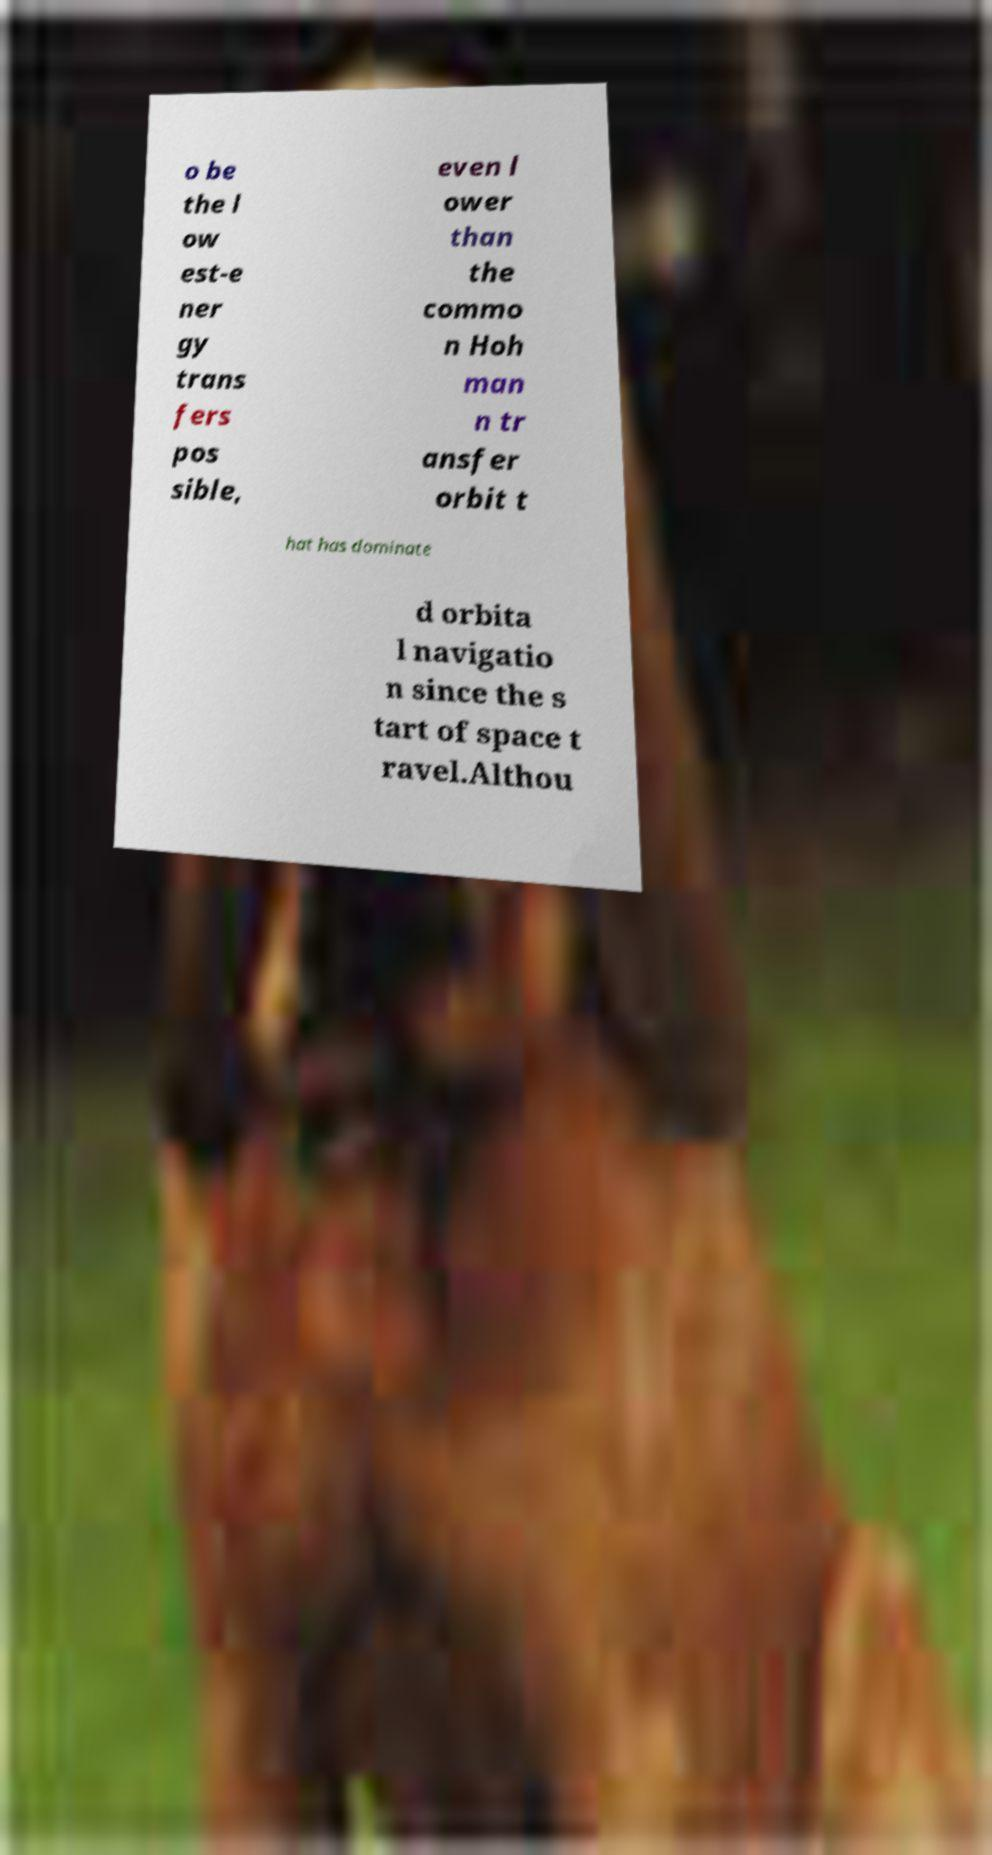Could you assist in decoding the text presented in this image and type it out clearly? o be the l ow est-e ner gy trans fers pos sible, even l ower than the commo n Hoh man n tr ansfer orbit t hat has dominate d orbita l navigatio n since the s tart of space t ravel.Althou 